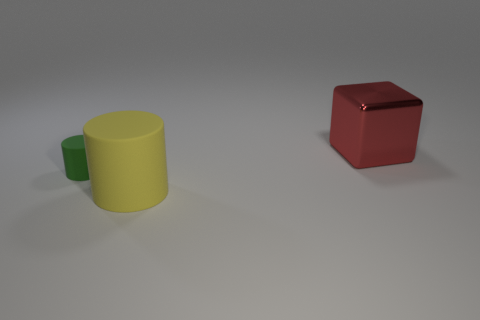There is a thing that is on the left side of the large thing in front of the red thing; is there a large red metallic block that is in front of it?
Provide a succinct answer. No. What is the size of the green matte cylinder?
Offer a very short reply. Small. How many yellow cylinders are the same size as the red metal thing?
Ensure brevity in your answer.  1. What material is the big yellow object that is the same shape as the tiny object?
Your response must be concise. Rubber. There is a thing that is both behind the big cylinder and in front of the big metallic thing; what is its shape?
Provide a succinct answer. Cylinder. There is a big thing that is behind the green matte object; what shape is it?
Keep it short and to the point. Cube. How many things are to the right of the green cylinder and in front of the big red cube?
Offer a terse response. 1. There is a green matte thing; is it the same size as the red object on the right side of the large matte cylinder?
Ensure brevity in your answer.  No. How big is the green object that is behind the large thing in front of the rubber cylinder that is behind the large yellow cylinder?
Your answer should be very brief. Small. There is a green thing that is on the left side of the big yellow matte cylinder; what size is it?
Make the answer very short. Small. 